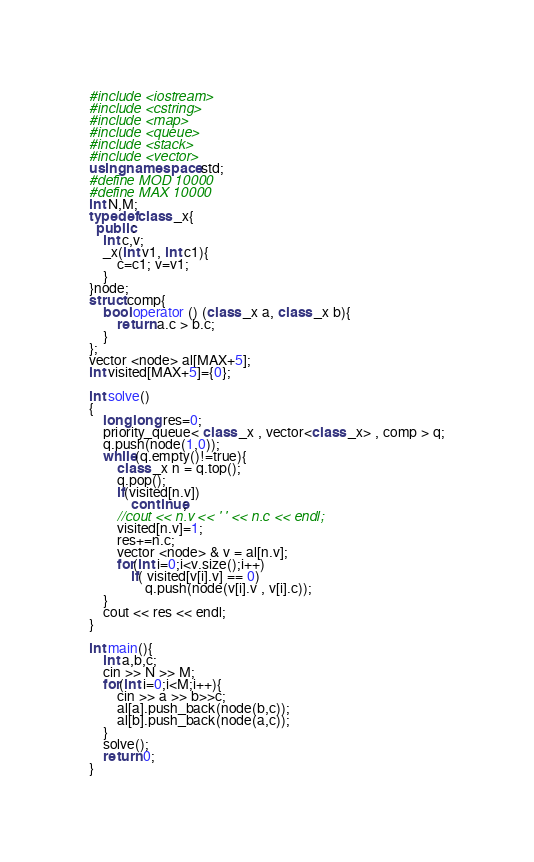Convert code to text. <code><loc_0><loc_0><loc_500><loc_500><_C++_>#include <iostream>
#include <cstring>
#include <map>
#include <queue>
#include <stack>
#include <vector>
using namespace std;
#define MOD 10000
#define MAX 10000
int N,M;
typedef class _x{
  public:
	int c,v;
	_x(int v1, int c1){
		c=c1; v=v1;
	}
}node;
struct comp{
	bool operator () (class _x a, class _x b){
		return a.c > b.c;
	}
};
vector <node> al[MAX+5];
int visited[MAX+5]={0};

int solve()
{
	long long res=0;
	priority_queue< class _x , vector<class _x> , comp > q;
	q.push(node(1,0));
	while(q.empty()!=true){
		class _x n = q.top();
		q.pop();
		if(visited[n.v])
			continue;
		//cout << n.v << ' ' << n.c << endl;
		visited[n.v]=1;
		res+=n.c;
		vector <node> & v = al[n.v];
		for(int i=0;i<v.size();i++)
			if( visited[v[i].v] == 0)
				q.push(node(v[i].v , v[i].c));
	}
	cout << res << endl;
}

int main(){
	int a,b,c;
	cin >> N >> M;
	for(int i=0;i<M;i++){
		cin >> a >> b>>c;
		al[a].push_back(node(b,c));
		al[b].push_back(node(a,c));
	}
	solve();
	return 0;
}
</code> 